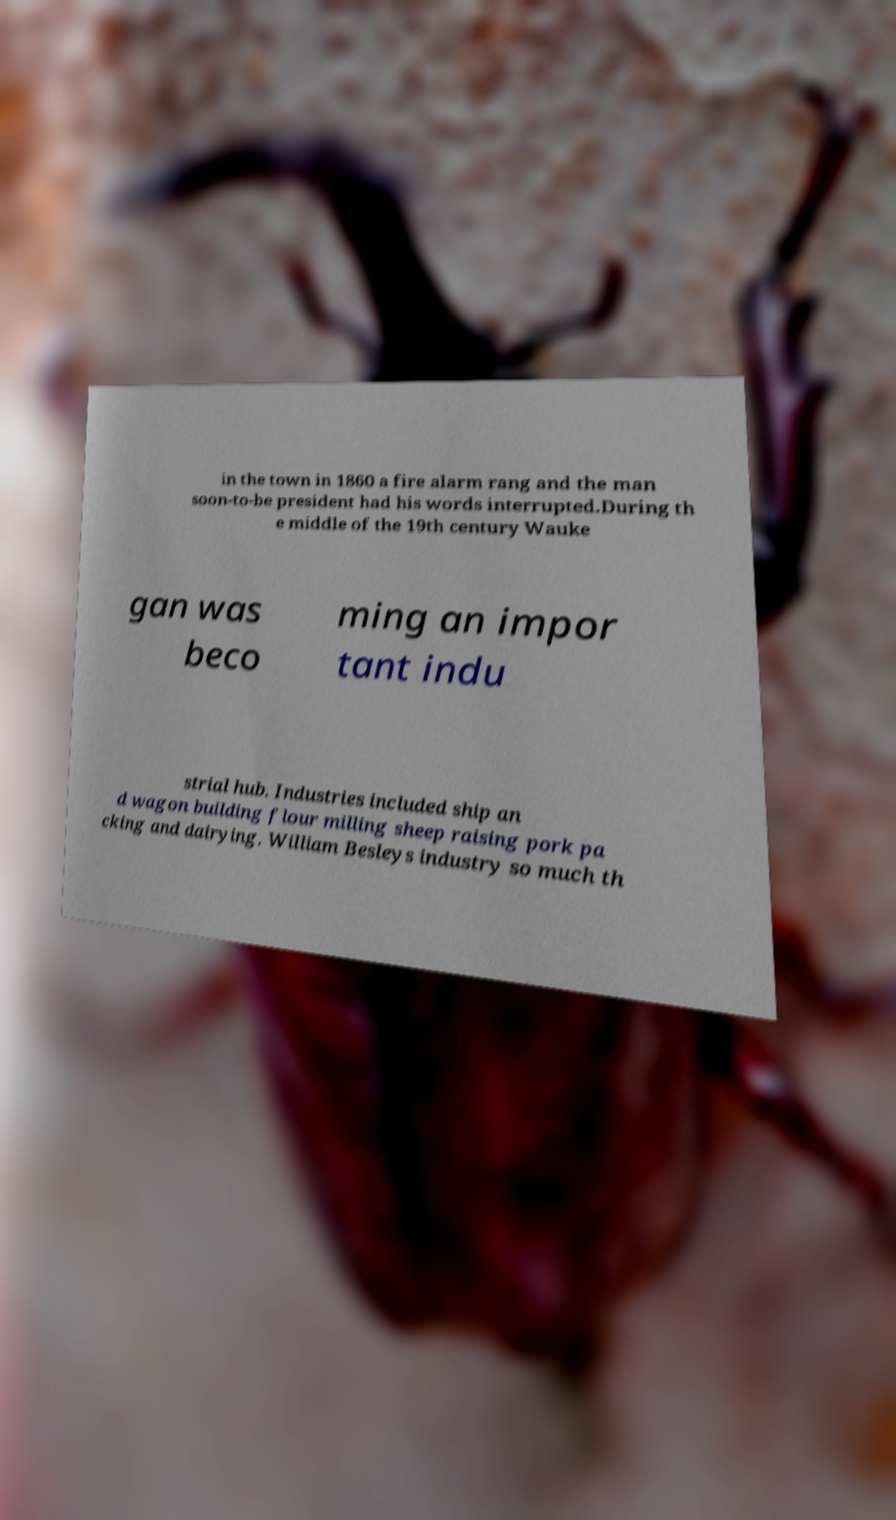What messages or text are displayed in this image? I need them in a readable, typed format. in the town in 1860 a fire alarm rang and the man soon-to-be president had his words interrupted.During th e middle of the 19th century Wauke gan was beco ming an impor tant indu strial hub. Industries included ship an d wagon building flour milling sheep raising pork pa cking and dairying. William Besleys industry so much th 